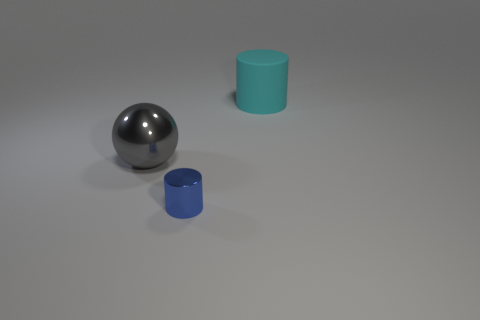Add 2 small brown shiny objects. How many objects exist? 5 Subtract 1 cylinders. How many cylinders are left? 1 Subtract all cylinders. How many objects are left? 1 Subtract all blue cylinders. How many cylinders are left? 1 Add 2 purple blocks. How many purple blocks exist? 2 Subtract 0 green balls. How many objects are left? 3 Subtract all blue cylinders. Subtract all green blocks. How many cylinders are left? 1 Subtract all large brown shiny cylinders. Subtract all small cylinders. How many objects are left? 2 Add 2 big balls. How many big balls are left? 3 